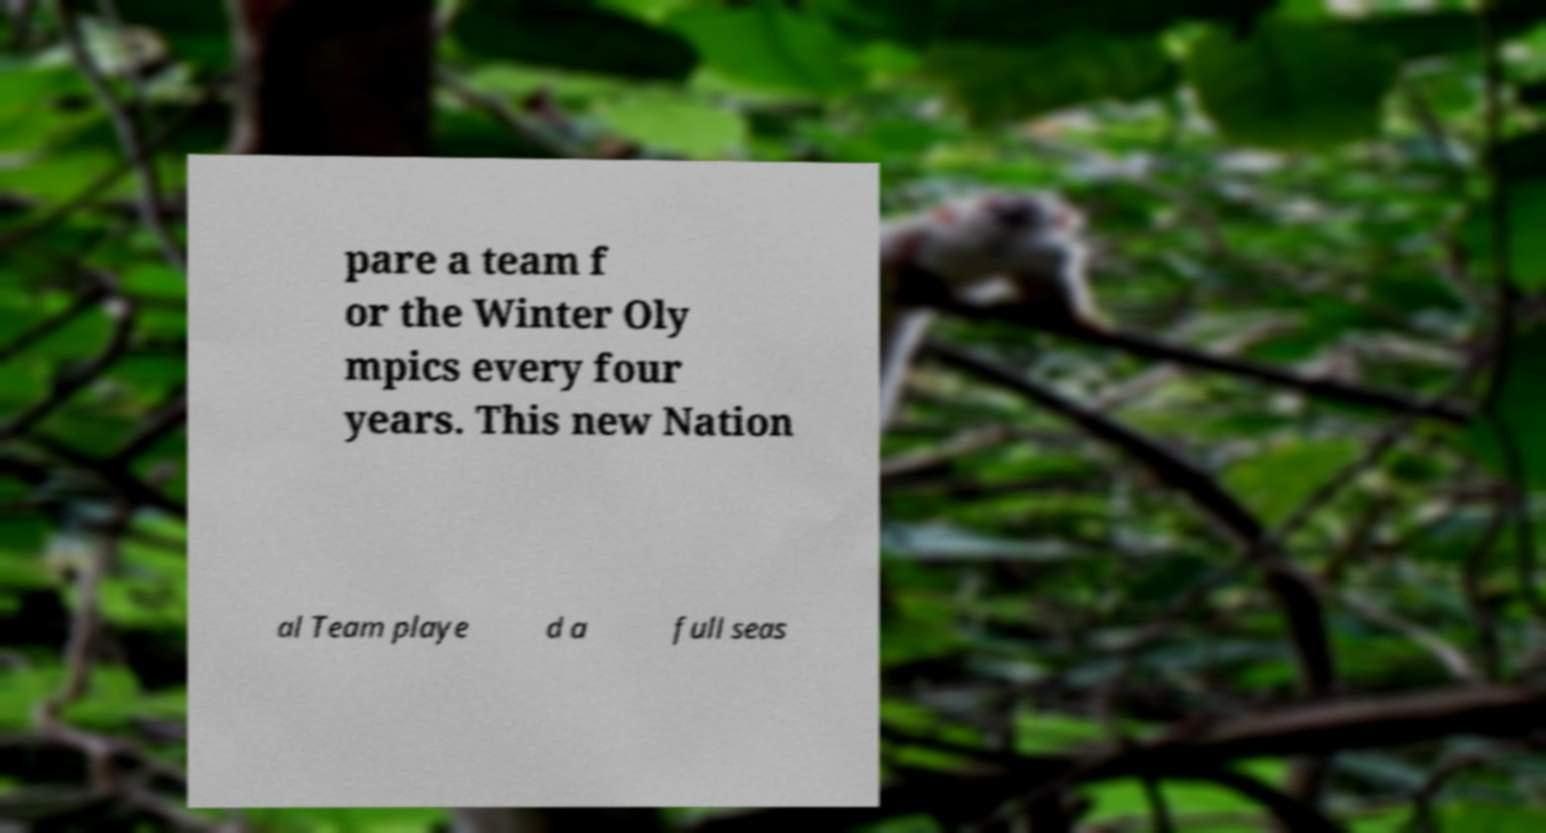Could you assist in decoding the text presented in this image and type it out clearly? pare a team f or the Winter Oly mpics every four years. This new Nation al Team playe d a full seas 